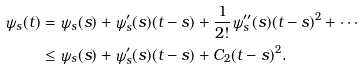<formula> <loc_0><loc_0><loc_500><loc_500>\psi _ { s } ( t ) & = \psi _ { s } ( s ) + \psi ^ { \prime } _ { s } ( s ) ( t - s ) + \frac { 1 } { 2 ! } \psi ^ { \prime \prime } _ { s } ( s ) ( t - s ) ^ { 2 } + \cdots \\ & \leq \psi _ { s } ( s ) + \psi ^ { \prime } _ { s } ( s ) ( t - s ) + C _ { 2 } ( t - s ) ^ { 2 } .</formula> 